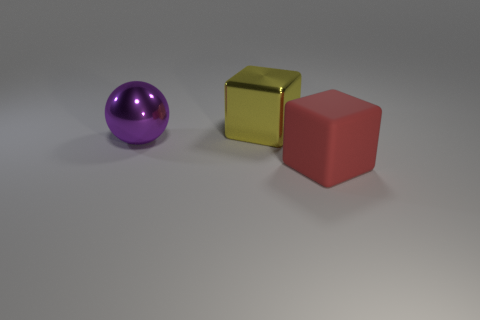Add 1 large green blocks. How many objects exist? 4 Add 1 purple objects. How many purple objects are left? 2 Add 3 small shiny spheres. How many small shiny spheres exist? 3 Subtract 0 gray cylinders. How many objects are left? 3 Subtract all spheres. How many objects are left? 2 Subtract 1 spheres. How many spheres are left? 0 Subtract all brown spheres. Subtract all purple cubes. How many spheres are left? 1 Subtract all cyan cylinders. How many gray blocks are left? 0 Subtract all large yellow shiny things. Subtract all large blocks. How many objects are left? 0 